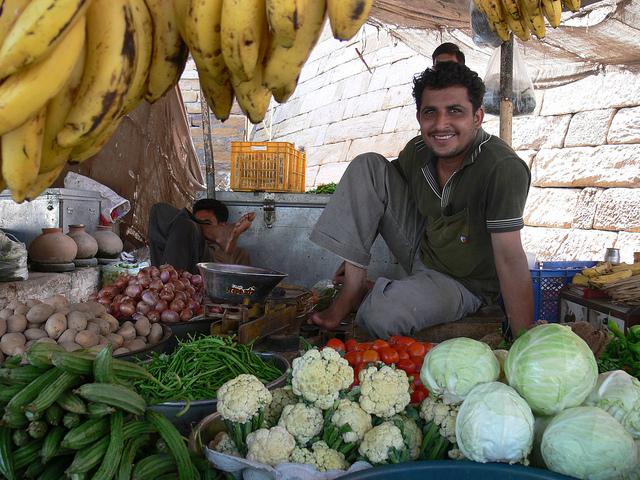Are the bananas in various stages of ripeness?
Keep it brief. No. Are most of the bananas yellow?
Give a very brief answer. Yes. Is the man going to eat all the food by himself?
Answer briefly. No. Where are the bananas?
Answer briefly. Hanging. Is there melons in the picture?
Write a very short answer. No. Are there any vegetables?
Keep it brief. Yes. What color are the man's pants?
Short answer required. Gray. Is the man sitting with his legs crossed?
Keep it brief. No. What fruit is hanging?
Concise answer only. Bananas. How many types of fruit is this man selling?
Quick response, please. 1. 